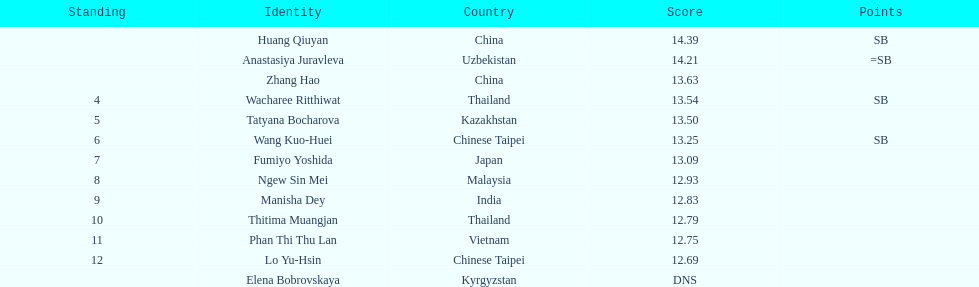How many athletes were from china? 2. 